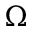<formula> <loc_0><loc_0><loc_500><loc_500>\Omega</formula> 